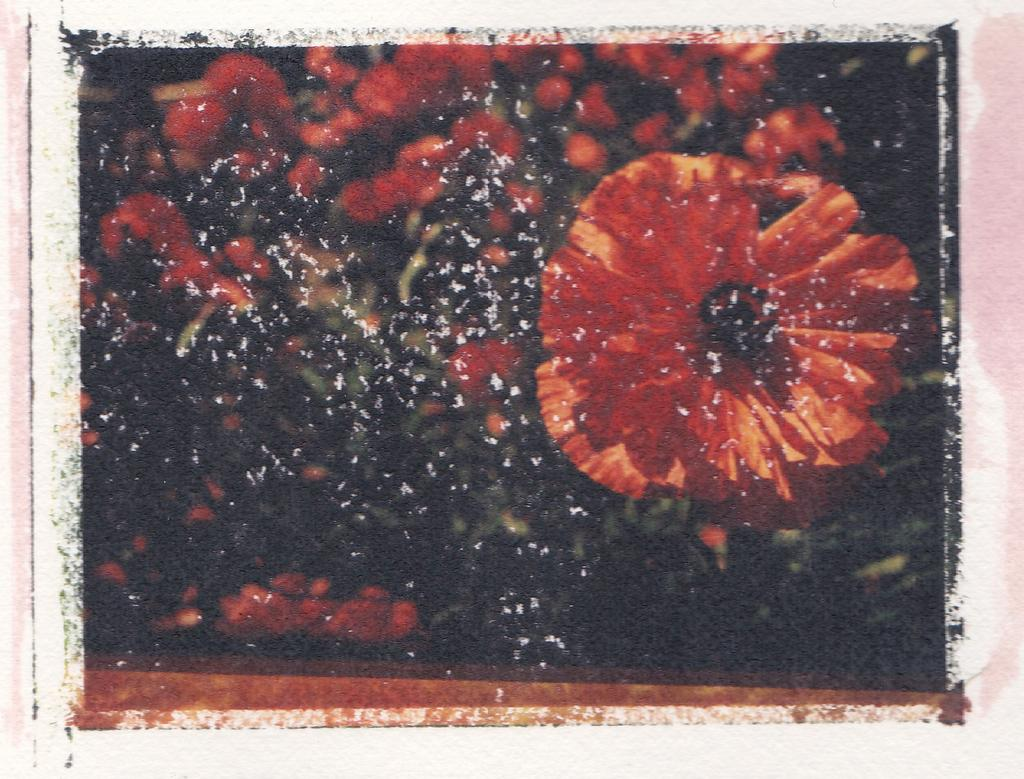What type of flowers can be seen in the image? There are red color flowers in the image. What color is the background of the image? The background of the image is black. What type of holiday is being celebrated in the image? There is no indication of a holiday being celebrated in the image. What form does the expansion of the flowers take in the image? There is no expansion of the flowers in the image, as they are stationary and not growing or changing shape. 